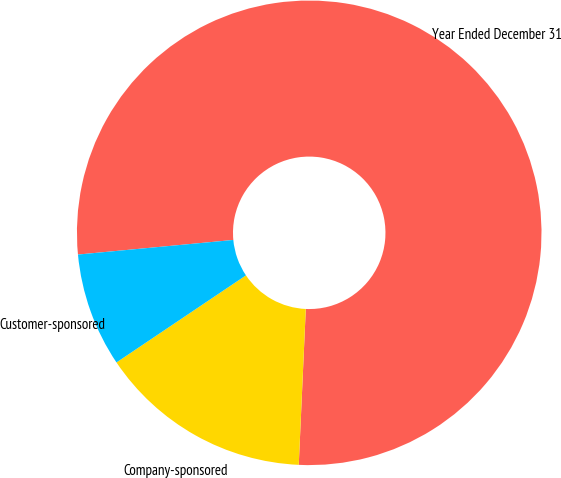Convert chart to OTSL. <chart><loc_0><loc_0><loc_500><loc_500><pie_chart><fcel>Year Ended December 31<fcel>Company-sponsored<fcel>Customer-sponsored<nl><fcel>77.21%<fcel>14.86%<fcel>7.93%<nl></chart> 